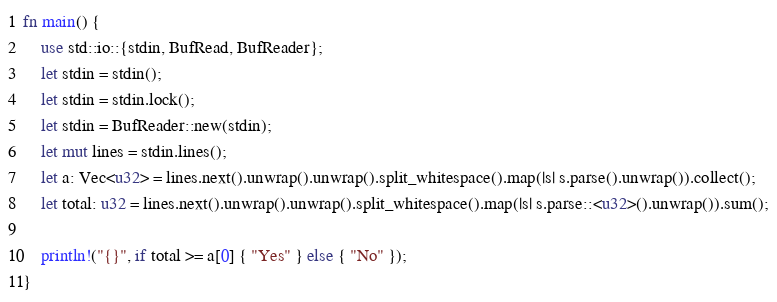<code> <loc_0><loc_0><loc_500><loc_500><_Rust_>fn main() {
    use std::io::{stdin, BufRead, BufReader};
    let stdin = stdin();
    let stdin = stdin.lock();
    let stdin = BufReader::new(stdin);
    let mut lines = stdin.lines();
    let a: Vec<u32> = lines.next().unwrap().unwrap().split_whitespace().map(|s| s.parse().unwrap()).collect();
    let total: u32 = lines.next().unwrap().unwrap().split_whitespace().map(|s| s.parse::<u32>().unwrap()).sum();

    println!("{}", if total >= a[0] { "Yes" } else { "No" });
}</code> 